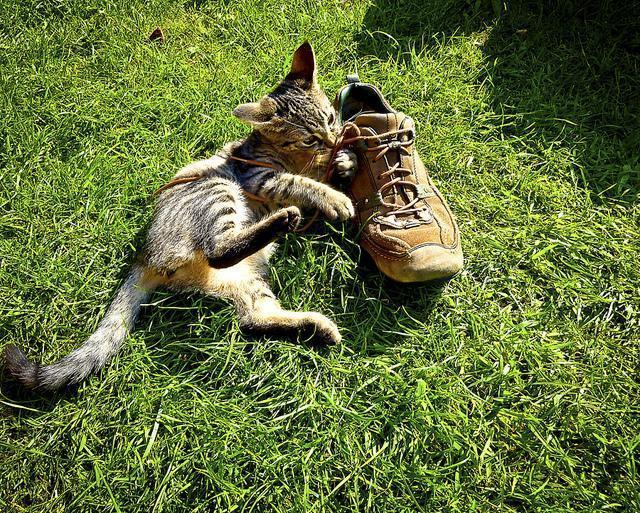How many dogs are on he bench in this image?
Give a very brief answer. 0. 